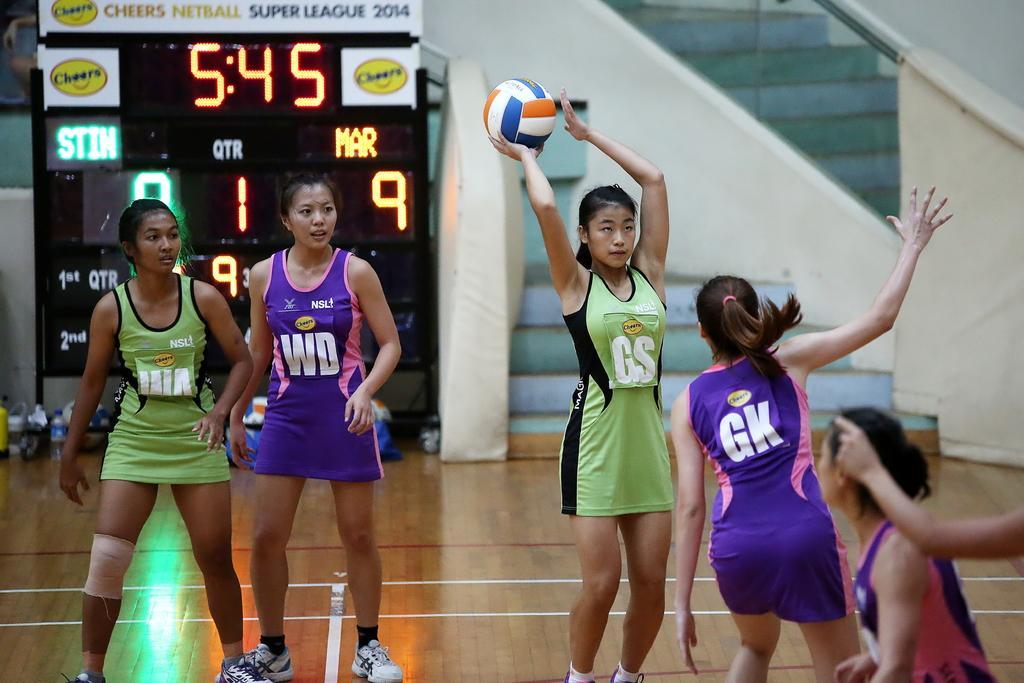Describe this image in one or two sentences. In this picture we can see a group of women on the ground, one woman is holding a ball and in the background we can see a scoreboard, bottle and some objects. 